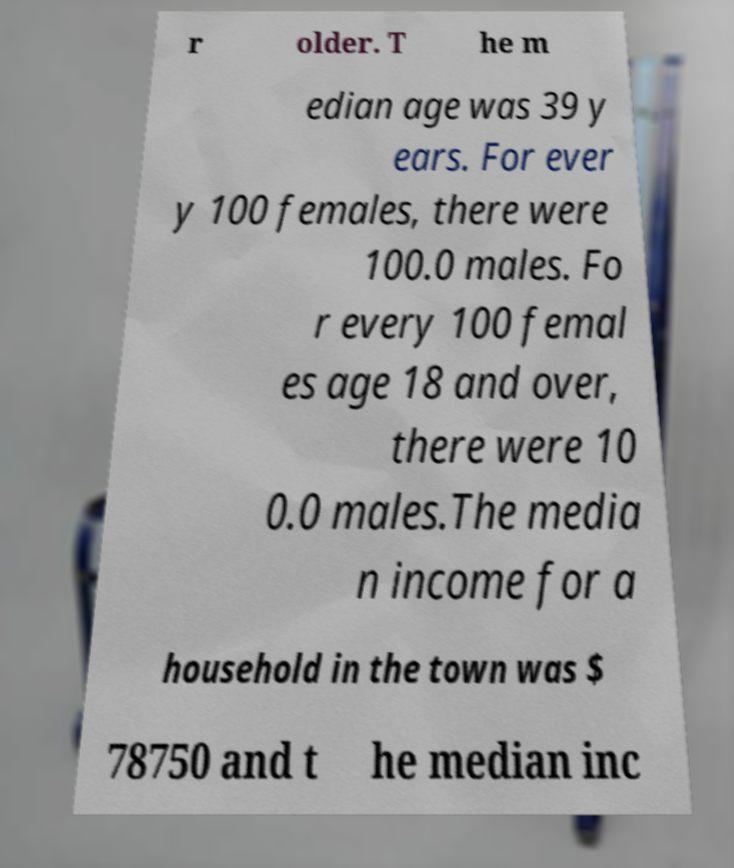What messages or text are displayed in this image? I need them in a readable, typed format. r older. T he m edian age was 39 y ears. For ever y 100 females, there were 100.0 males. Fo r every 100 femal es age 18 and over, there were 10 0.0 males.The media n income for a household in the town was $ 78750 and t he median inc 